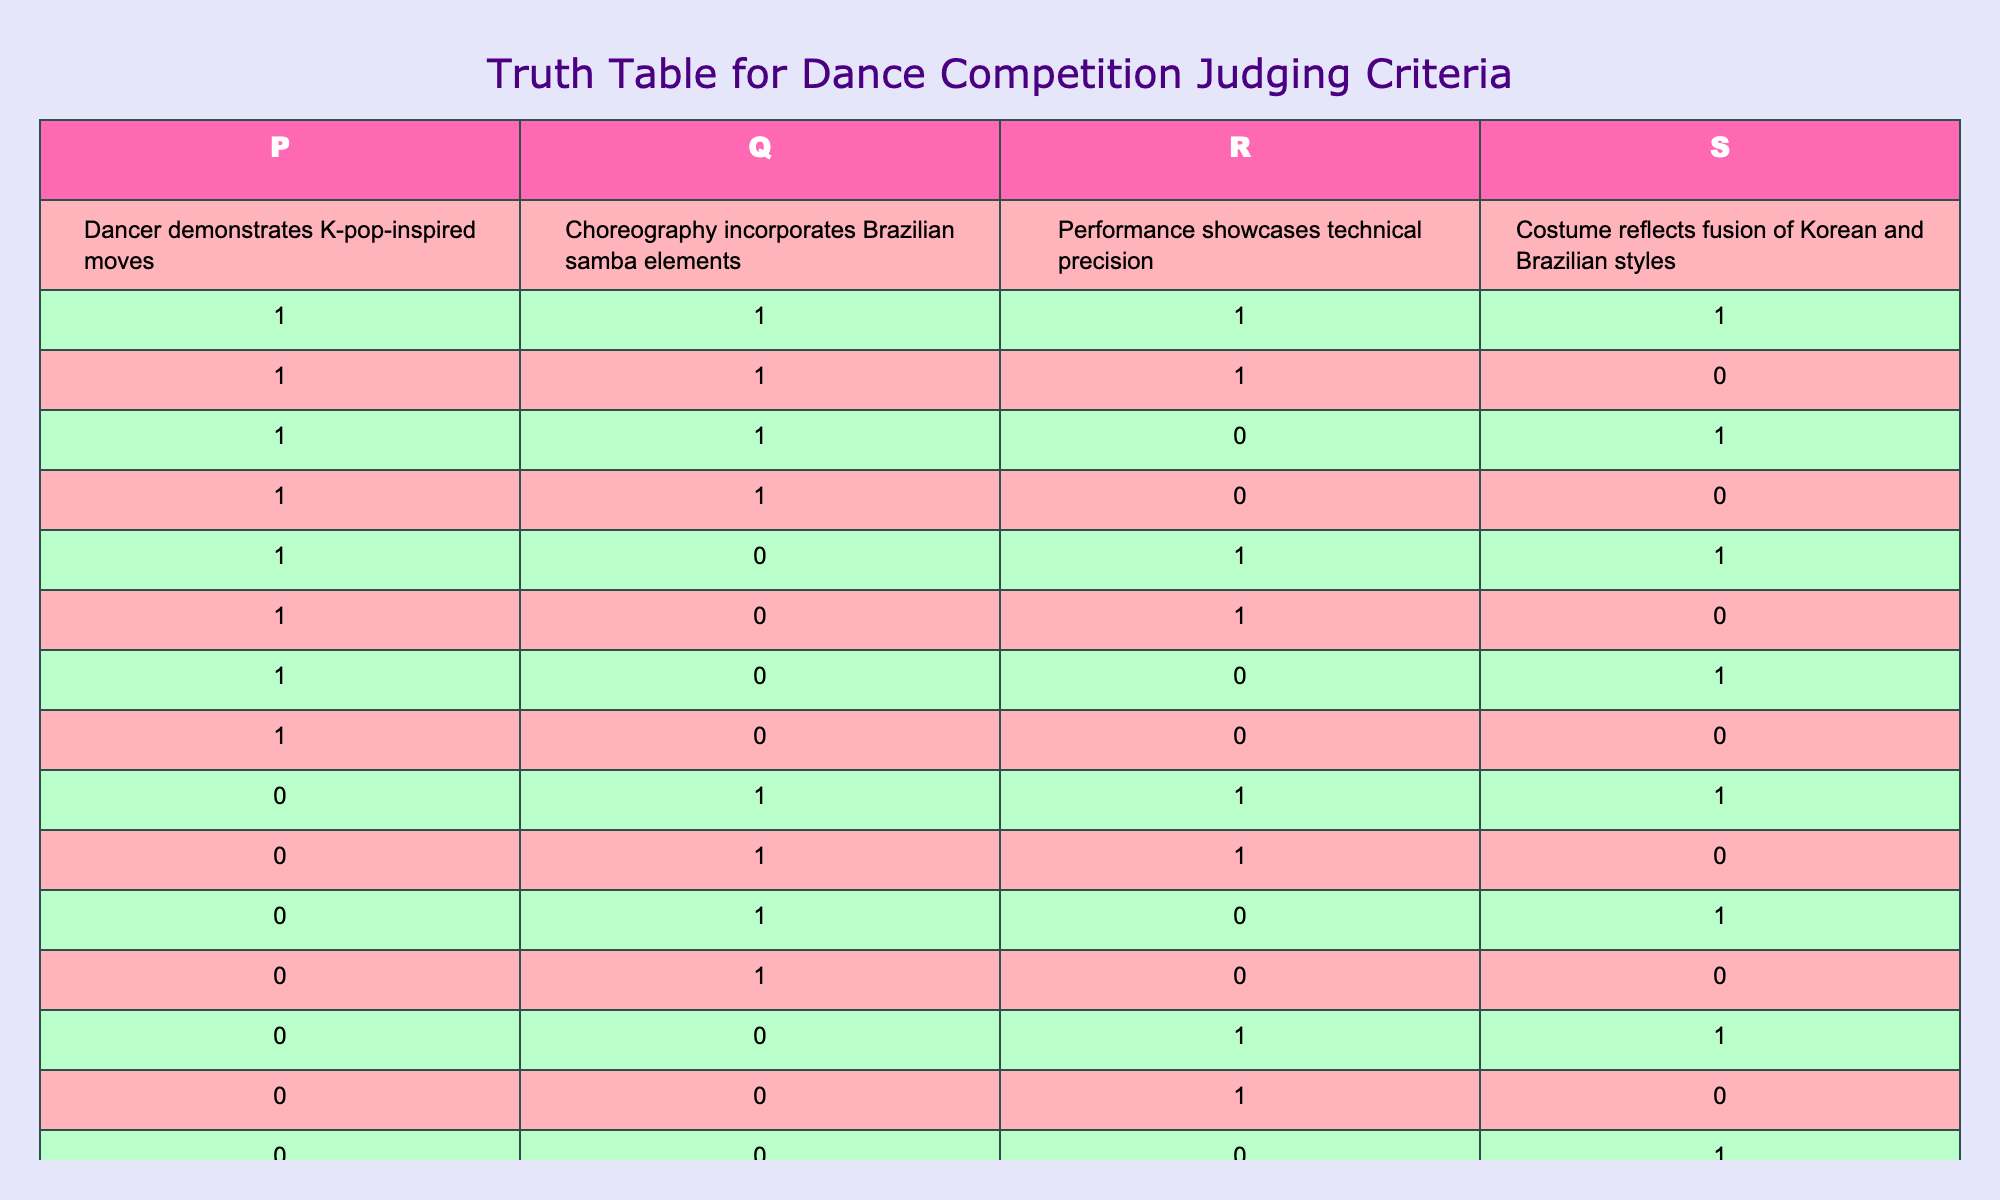What is the total number of dancers that showcased all four criteria? In the table, the row where all criteria (P, Q, R, S) have values of 1 indicates dancers meeting all four criteria. There is only one such row at the top of the table.
Answer: 1 How many dancers incorporated Brazilian samba elements in their choreography but did not demonstrate K-pop-inspired moves? To find this, we look for rows where Q is 1 and P is 0. There are four such rows (the ones with values Q=1, P=0).
Answer: 4 Is it true that all dancers who demonstrated K-pop-inspired moves also showcased technical precision? We need to examine all rows where P is 1; in these rows, we check if R is 1. We find that R is not 1 for some sources where P is 1. Therefore, this statement is false.
Answer: No What is the average number of criteria met by dancers who have Brazilian samba elements in their choreography? To calculate this, we sum up the number of criteria met (the sum of P, Q, R, S) for all rows where Q=1. Then divide that sum by the number of such rows, which totals 7 criteria over 5 dancers, leading to an average of 1.4.
Answer: 1.4 How many dancers showcased technical precision and also had costumes reflecting a fusion of styles? We focus on rows where R=1 and S=1. Counting these occurrences yields three rows that satisfy this condition.
Answer: 3 What is the combination of dancers that performed K-pop-influenced moves but did not incorporate Brazilian elements? We look for rows where P=1 and Q=0. Three dancers fit this profile, indicating they embodied K-pop moves without incorporating Brazilian samba.
Answer: 3 What's the maximum number of criteria any dancer met, and how many dancers achieved this? We check the rows for the maximum sum of P, Q, R, and S for a single row. The first row has all criteria met for one dancer, which is four in total.
Answer: 1 dancer met 4 criteria Did any dancers avoid K-pop moves but still demonstrate technical precision? We examine rows where P=0 and R=1. We find three rows meeting this criterion. Thus, the answer is yes.
Answer: Yes How many total dancers included K-pop moves in their performance? We look for how many rows have P=1. Counting such rows gives us five dancers incorporating K-pop elements.
Answer: 5 